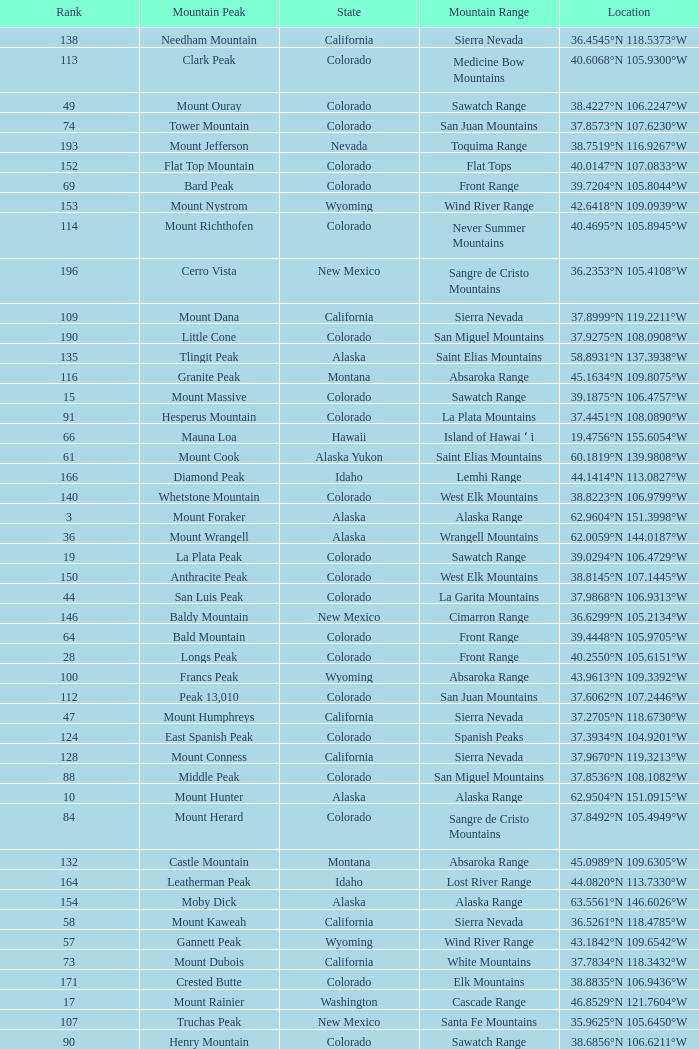What is the mountain range when the mountain peak is mauna kea? Island of Hawai ʻ i. 